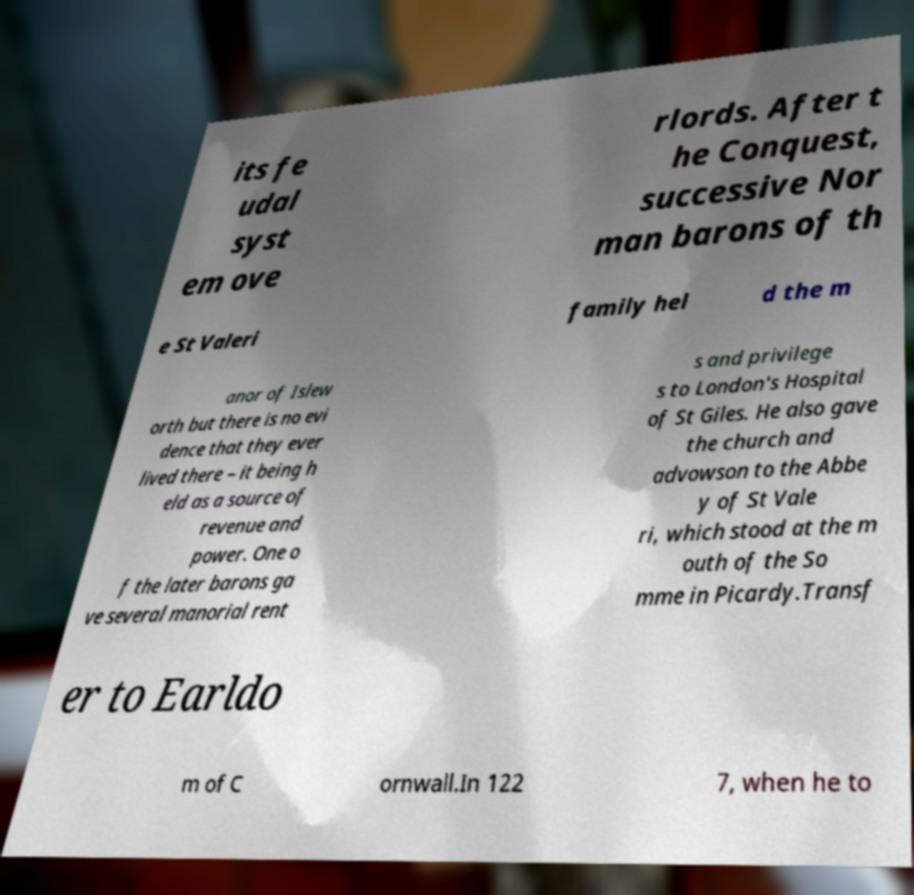Please identify and transcribe the text found in this image. its fe udal syst em ove rlords. After t he Conquest, successive Nor man barons of th e St Valeri family hel d the m anor of Islew orth but there is no evi dence that they ever lived there – it being h eld as a source of revenue and power. One o f the later barons ga ve several manorial rent s and privilege s to London's Hospital of St Giles. He also gave the church and advowson to the Abbe y of St Vale ri, which stood at the m outh of the So mme in Picardy.Transf er to Earldo m of C ornwall.In 122 7, when he to 